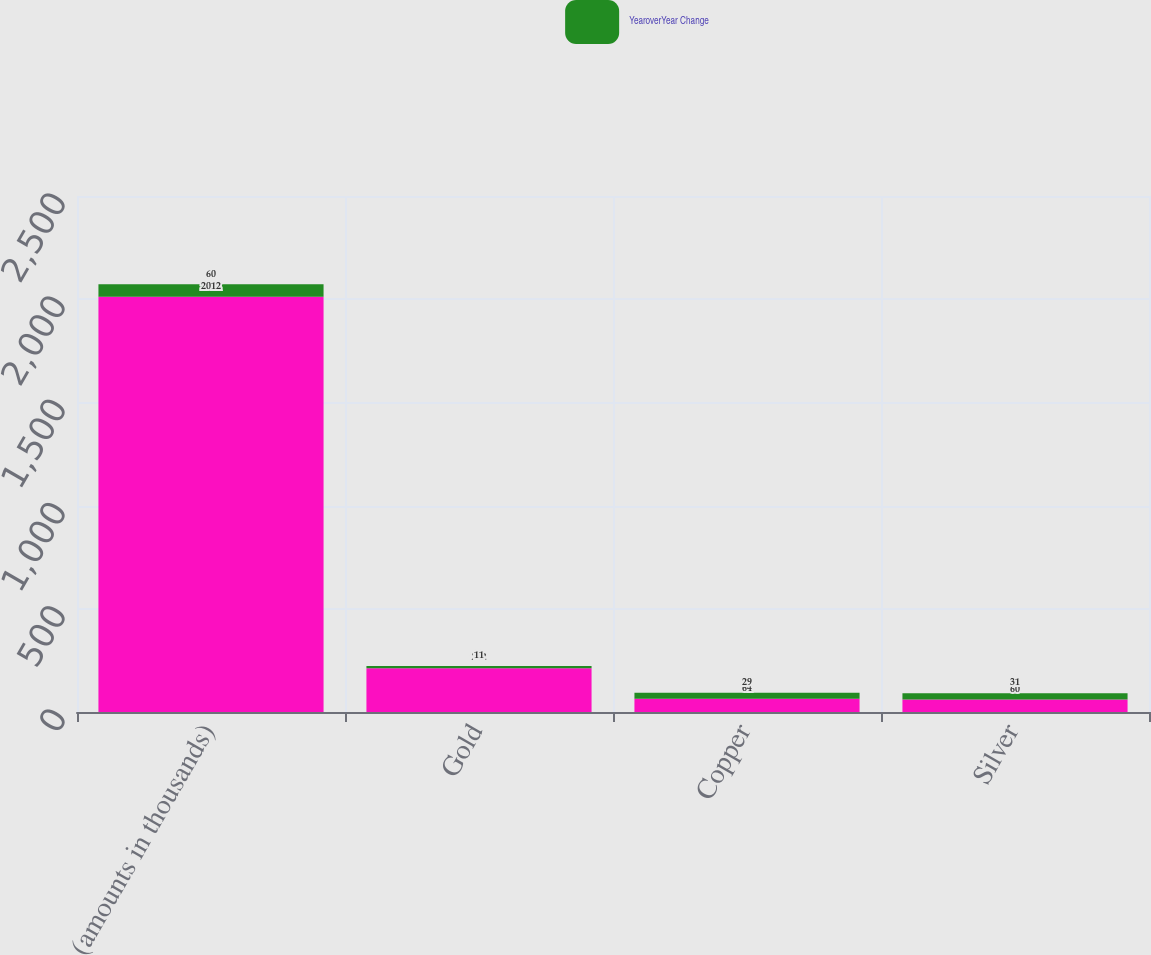Convert chart to OTSL. <chart><loc_0><loc_0><loc_500><loc_500><stacked_bar_chart><ecel><fcel>(amounts in thousands)<fcel>Gold<fcel>Copper<fcel>Silver<nl><fcel>nan<fcel>2012<fcel>212<fcel>64<fcel>60<nl><fcel>YearoverYear Change<fcel>60<fcel>11<fcel>29<fcel>31<nl></chart> 